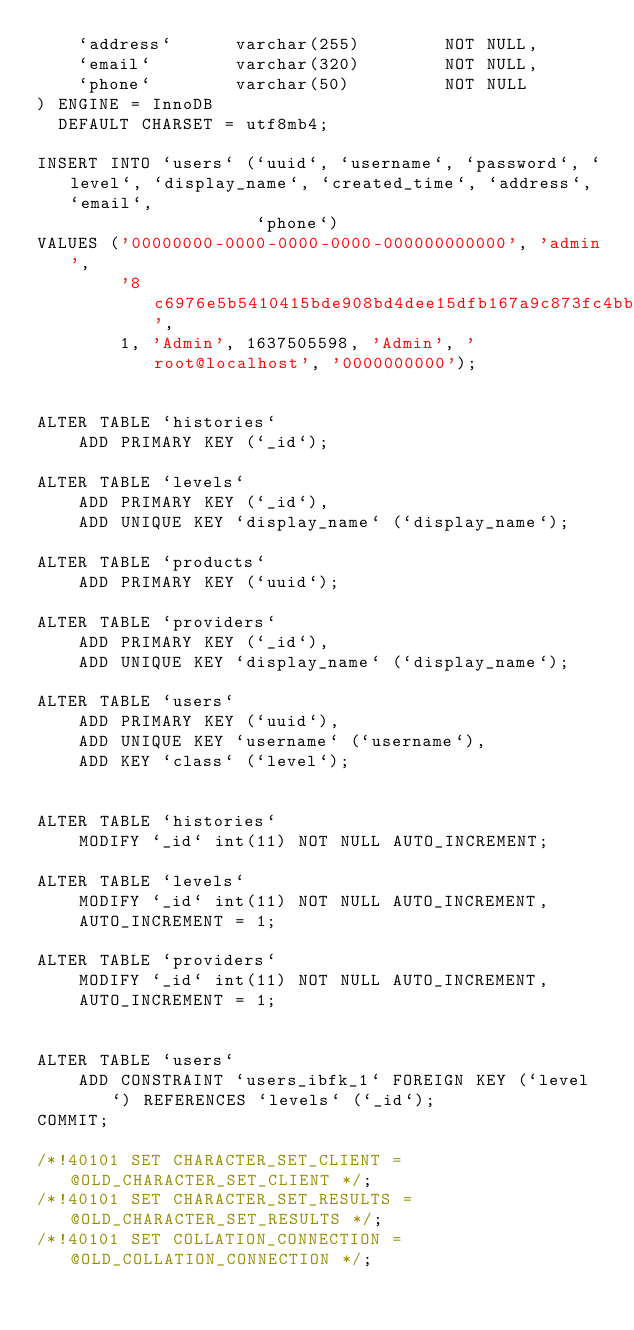Convert code to text. <code><loc_0><loc_0><loc_500><loc_500><_SQL_>    `address`      varchar(255)        NOT NULL,
    `email`        varchar(320)        NOT NULL,
    `phone`        varchar(50)         NOT NULL
) ENGINE = InnoDB
  DEFAULT CHARSET = utf8mb4;

INSERT INTO `users` (`uuid`, `username`, `password`, `level`, `display_name`, `created_time`, `address`, `email`,
                     `phone`)
VALUES ('00000000-0000-0000-0000-000000000000', 'admin',
        '8c6976e5b5410415bde908bd4dee15dfb167a9c873fc4bb8a81f6f2ab448a918',
        1, 'Admin', 1637505598, 'Admin', 'root@localhost', '0000000000');


ALTER TABLE `histories`
    ADD PRIMARY KEY (`_id`);

ALTER TABLE `levels`
    ADD PRIMARY KEY (`_id`),
    ADD UNIQUE KEY `display_name` (`display_name`);

ALTER TABLE `products`
    ADD PRIMARY KEY (`uuid`);

ALTER TABLE `providers`
    ADD PRIMARY KEY (`_id`),
    ADD UNIQUE KEY `display_name` (`display_name`);

ALTER TABLE `users`
    ADD PRIMARY KEY (`uuid`),
    ADD UNIQUE KEY `username` (`username`),
    ADD KEY `class` (`level`);


ALTER TABLE `histories`
    MODIFY `_id` int(11) NOT NULL AUTO_INCREMENT;

ALTER TABLE `levels`
    MODIFY `_id` int(11) NOT NULL AUTO_INCREMENT,
    AUTO_INCREMENT = 1;

ALTER TABLE `providers`
    MODIFY `_id` int(11) NOT NULL AUTO_INCREMENT,
    AUTO_INCREMENT = 1;


ALTER TABLE `users`
    ADD CONSTRAINT `users_ibfk_1` FOREIGN KEY (`level`) REFERENCES `levels` (`_id`);
COMMIT;

/*!40101 SET CHARACTER_SET_CLIENT = @OLD_CHARACTER_SET_CLIENT */;
/*!40101 SET CHARACTER_SET_RESULTS = @OLD_CHARACTER_SET_RESULTS */;
/*!40101 SET COLLATION_CONNECTION = @OLD_COLLATION_CONNECTION */;</code> 